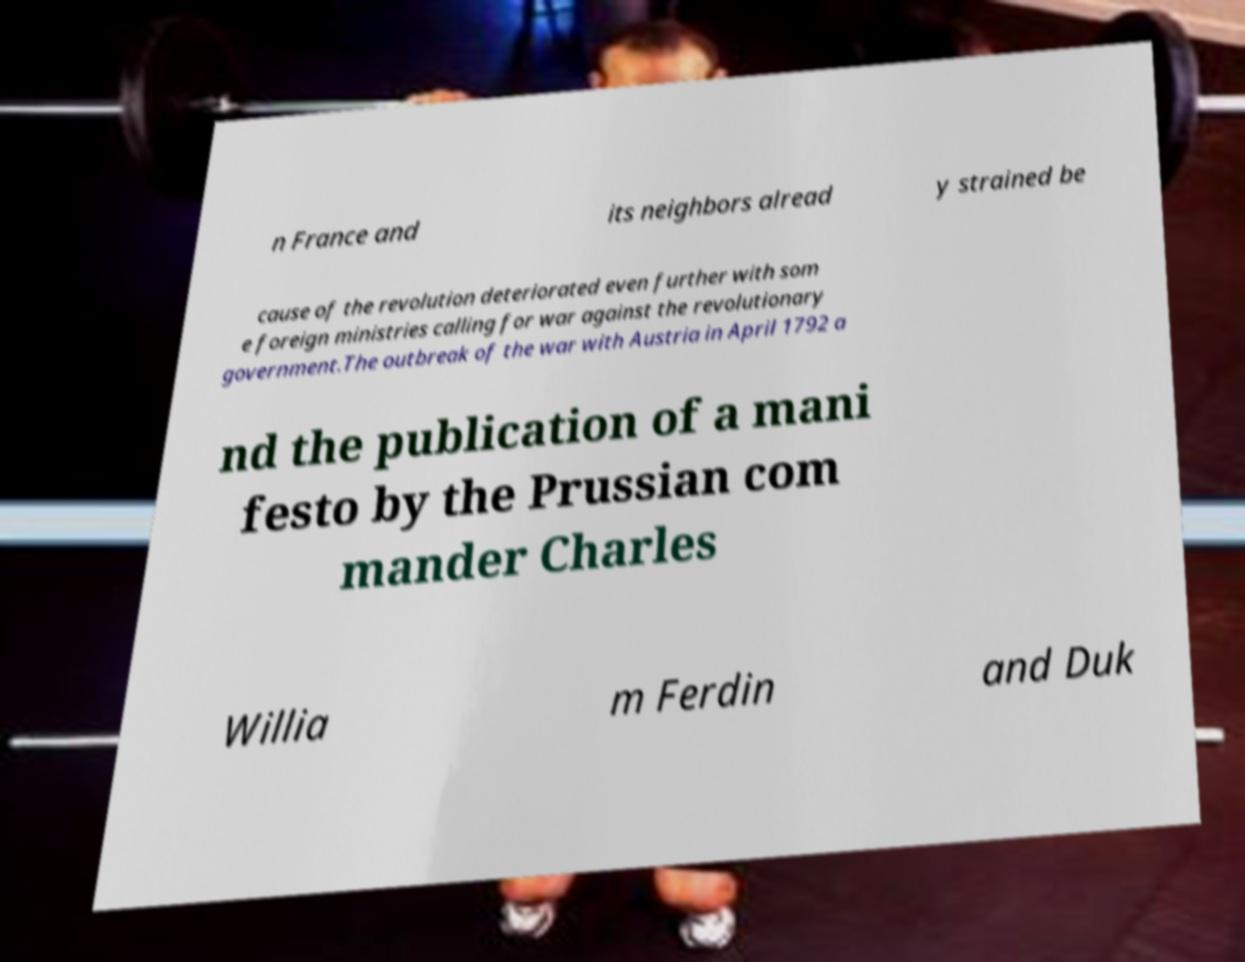What messages or text are displayed in this image? I need them in a readable, typed format. n France and its neighbors alread y strained be cause of the revolution deteriorated even further with som e foreign ministries calling for war against the revolutionary government.The outbreak of the war with Austria in April 1792 a nd the publication of a mani festo by the Prussian com mander Charles Willia m Ferdin and Duk 